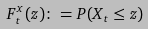<formula> <loc_0><loc_0><loc_500><loc_500>F ^ { x } _ { t } ( z ) \colon = P ( X _ { t } \leq z )</formula> 